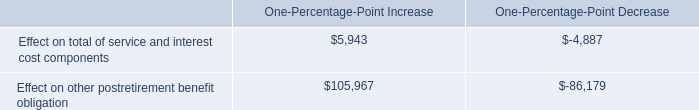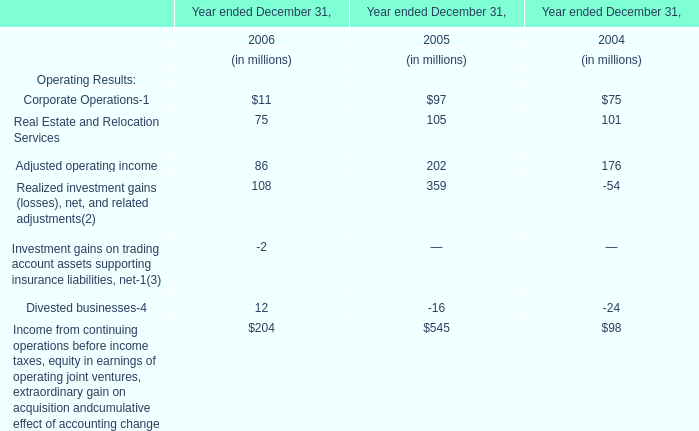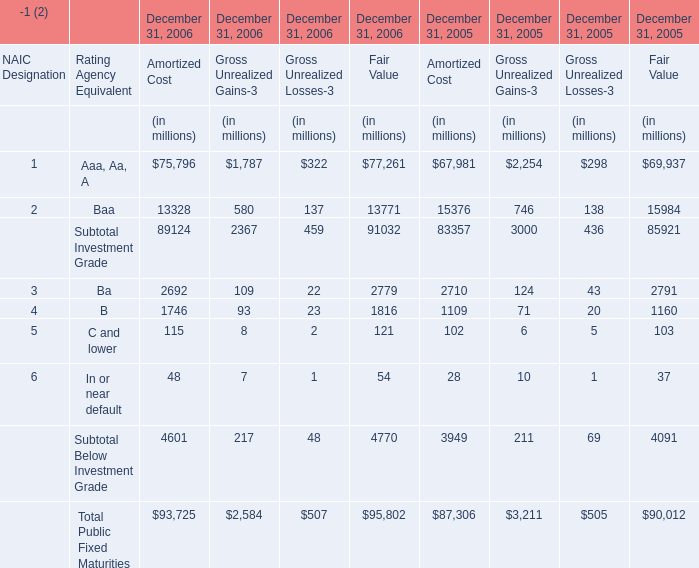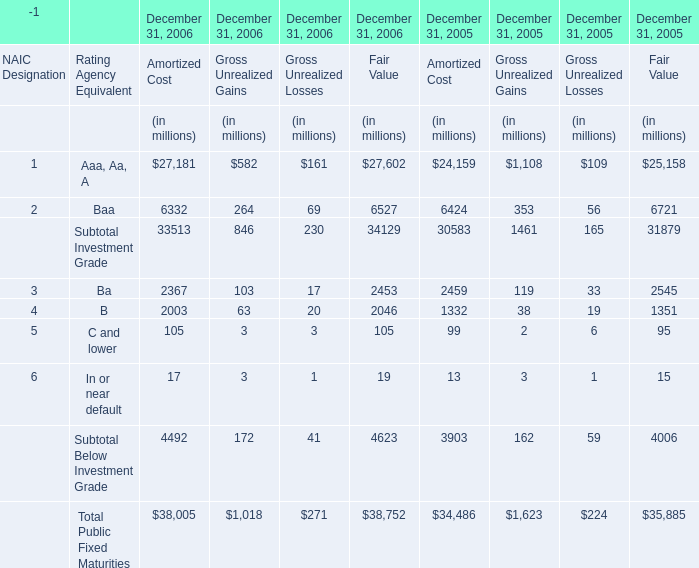What's the sum of all Amortized Cost that are greater than10000 in 2006 for December 31, 2006? (in million) 
Computations: (75796 + 13328)
Answer: 89124.0. 